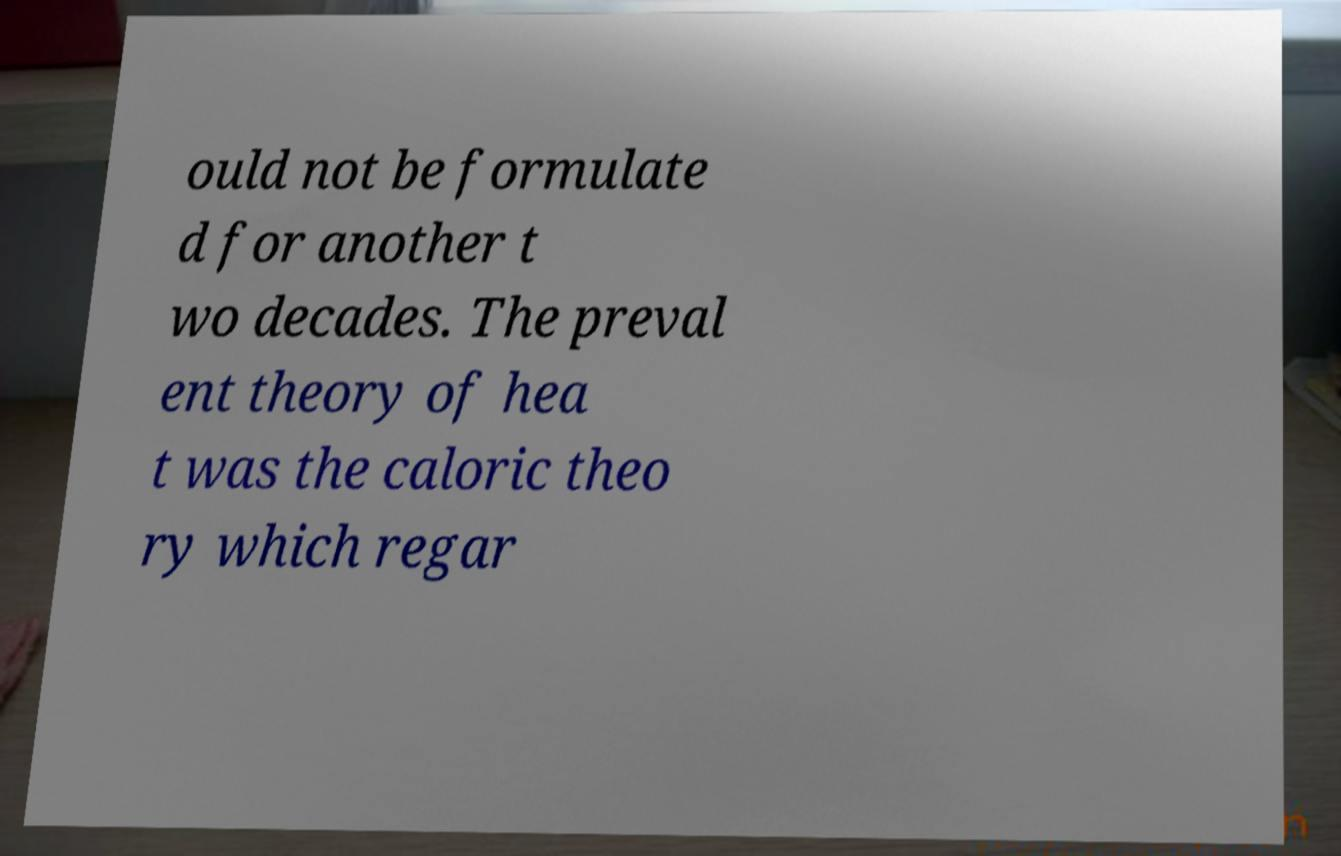Could you extract and type out the text from this image? ould not be formulate d for another t wo decades. The preval ent theory of hea t was the caloric theo ry which regar 